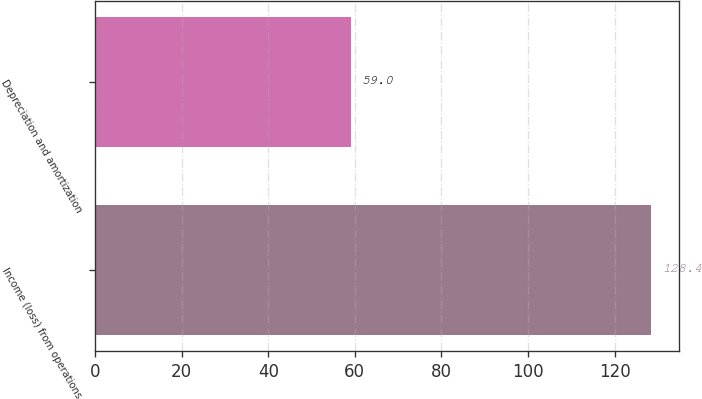Convert chart to OTSL. <chart><loc_0><loc_0><loc_500><loc_500><bar_chart><fcel>Income (loss) from operations<fcel>Depreciation and amortization<nl><fcel>128.4<fcel>59<nl></chart> 